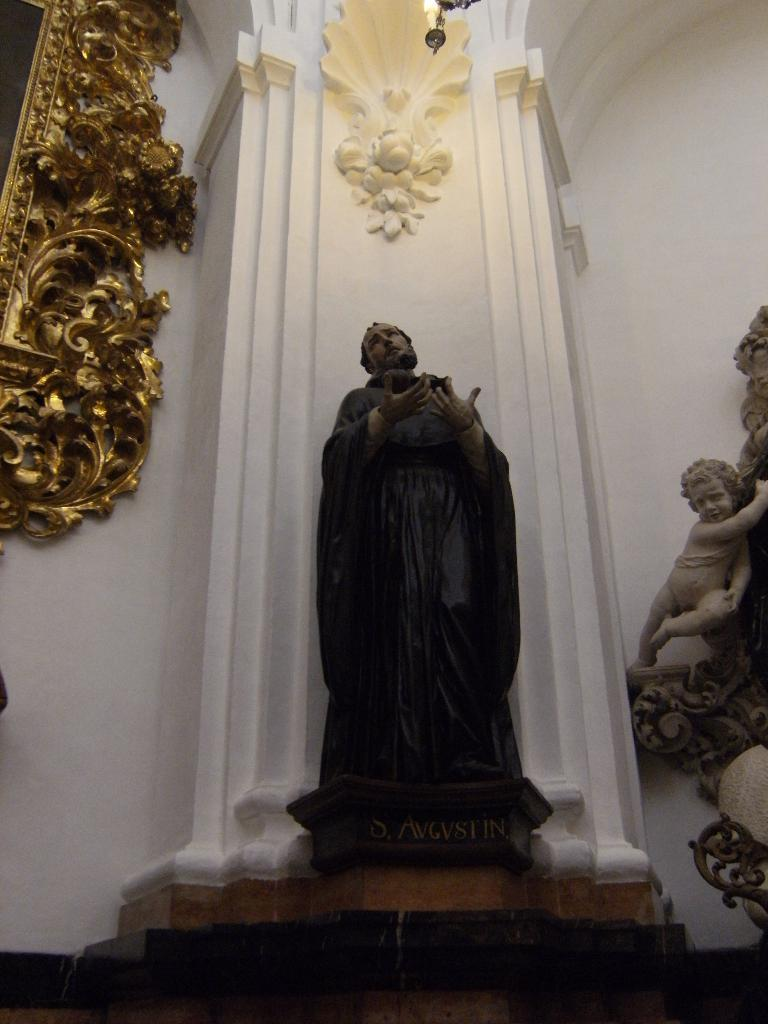What is the main subject in the image? There is a sculpture in front of a pillar in the image. Are there any other sculptures or statues in the image? Yes, there is another statue beside the first sculpture. What can be seen on the left side of the image? There is a carving done around a frame on the left side of the image. What type of mouth does the sculpture have in the image? There is no mention of a mouth on the sculpture in the provided facts, so it cannot be determined from the image. 